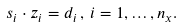<formula> <loc_0><loc_0><loc_500><loc_500>s _ { i } \cdot z _ { i } = d _ { i } \, , \, i = 1 , \dots , n _ { x } .</formula> 